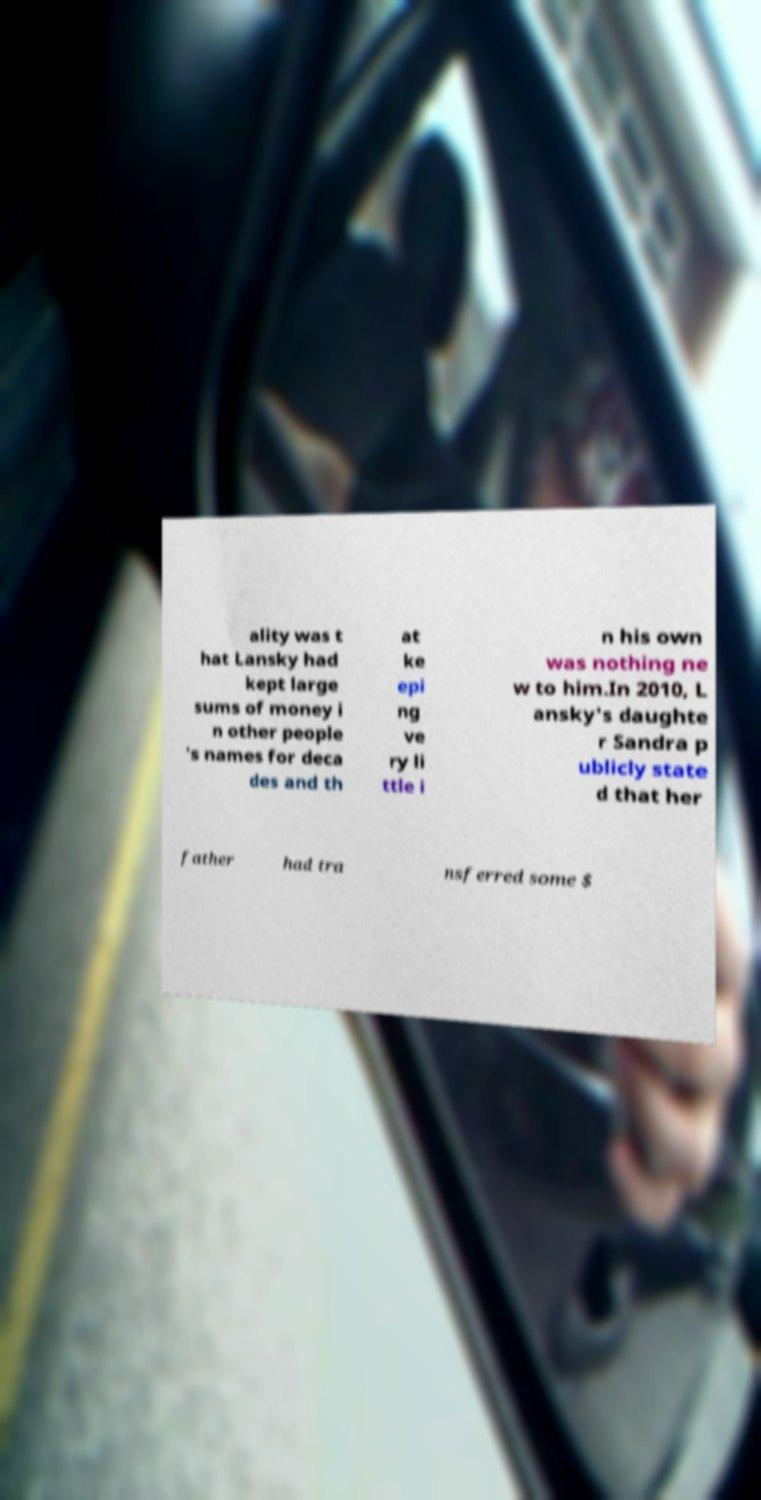I need the written content from this picture converted into text. Can you do that? ality was t hat Lansky had kept large sums of money i n other people 's names for deca des and th at ke epi ng ve ry li ttle i n his own was nothing ne w to him.In 2010, L ansky's daughte r Sandra p ublicly state d that her father had tra nsferred some $ 